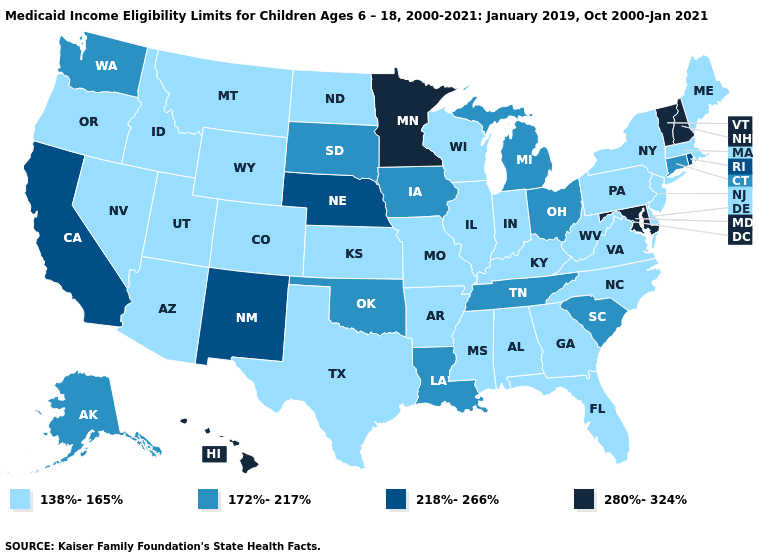Name the states that have a value in the range 280%-324%?
Answer briefly. Hawaii, Maryland, Minnesota, New Hampshire, Vermont. Does North Carolina have the same value as Kansas?
Quick response, please. Yes. Which states hav the highest value in the Northeast?
Be succinct. New Hampshire, Vermont. Among the states that border Nebraska , does South Dakota have the lowest value?
Answer briefly. No. How many symbols are there in the legend?
Write a very short answer. 4. Which states have the lowest value in the South?
Give a very brief answer. Alabama, Arkansas, Delaware, Florida, Georgia, Kentucky, Mississippi, North Carolina, Texas, Virginia, West Virginia. What is the value of New Hampshire?
Be succinct. 280%-324%. Which states have the lowest value in the MidWest?
Give a very brief answer. Illinois, Indiana, Kansas, Missouri, North Dakota, Wisconsin. Name the states that have a value in the range 172%-217%?
Short answer required. Alaska, Connecticut, Iowa, Louisiana, Michigan, Ohio, Oklahoma, South Carolina, South Dakota, Tennessee, Washington. What is the highest value in the Northeast ?
Concise answer only. 280%-324%. What is the value of Pennsylvania?
Give a very brief answer. 138%-165%. What is the lowest value in the MidWest?
Keep it brief. 138%-165%. Name the states that have a value in the range 138%-165%?
Short answer required. Alabama, Arizona, Arkansas, Colorado, Delaware, Florida, Georgia, Idaho, Illinois, Indiana, Kansas, Kentucky, Maine, Massachusetts, Mississippi, Missouri, Montana, Nevada, New Jersey, New York, North Carolina, North Dakota, Oregon, Pennsylvania, Texas, Utah, Virginia, West Virginia, Wisconsin, Wyoming. Does Pennsylvania have the lowest value in the Northeast?
Quick response, please. Yes. Does Minnesota have the highest value in the USA?
Be succinct. Yes. 